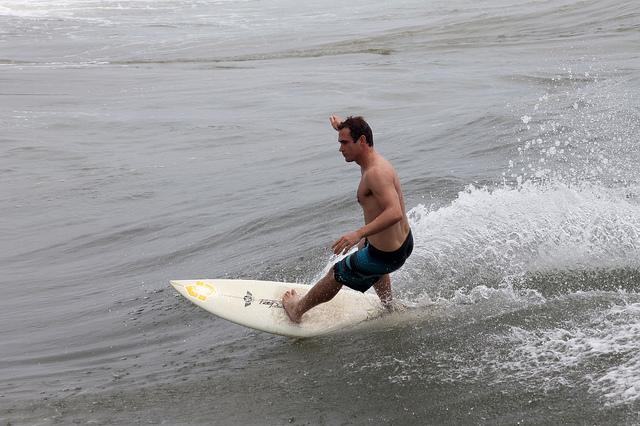What type of outfit is the man wearing?
Be succinct. Swim trunks. Is the man going to fall off the surfboard?
Answer briefly. No. Is this person an experienced surfer?
Quick response, please. Yes. Is the man's posture poor?
Answer briefly. No. Is the woman wearing a vest?
Concise answer only. No. What is the man doing?
Be succinct. Surfing. Is the man close to shore?
Concise answer only. Yes. 